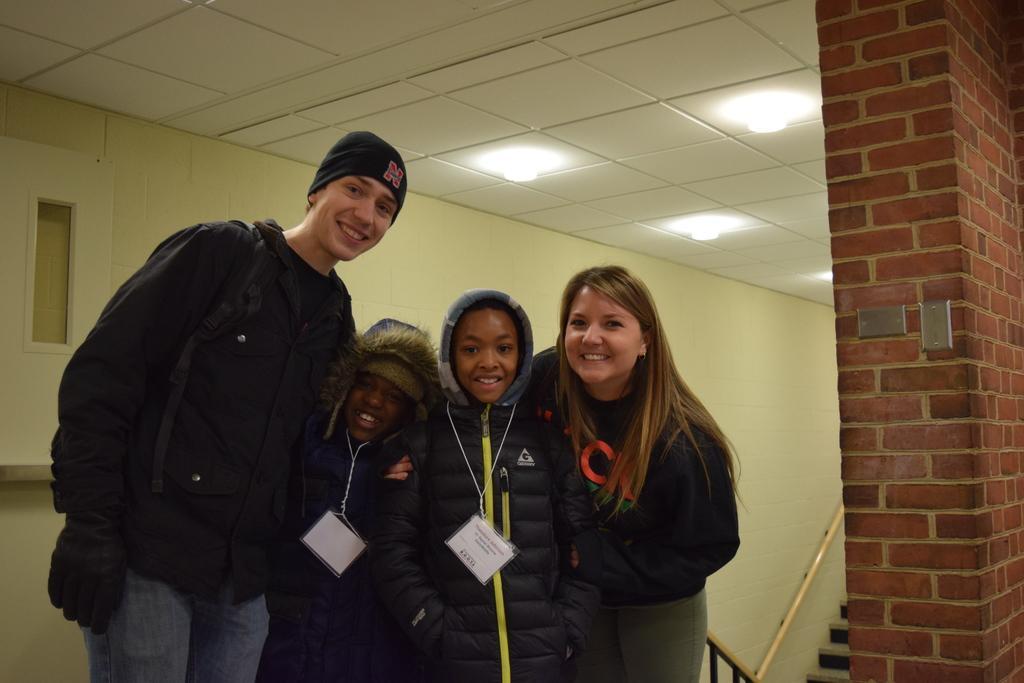Describe this image in one or two sentences. In this image we can see people standing and smiling. In the background there is a wall and we can see lights. At the bottom there are stairs. 